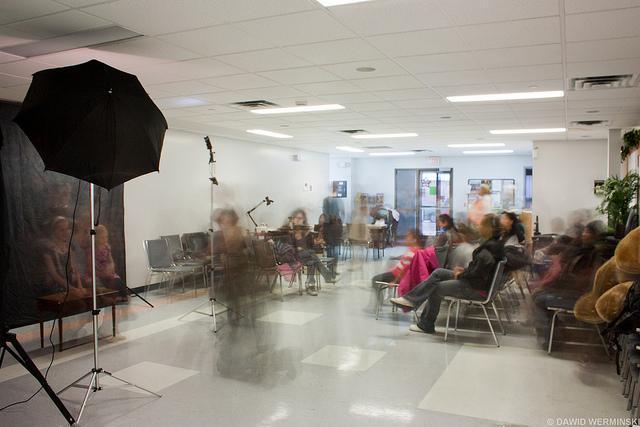How many people can you see?
Give a very brief answer. 4. How many chairs are visible?
Give a very brief answer. 2. 